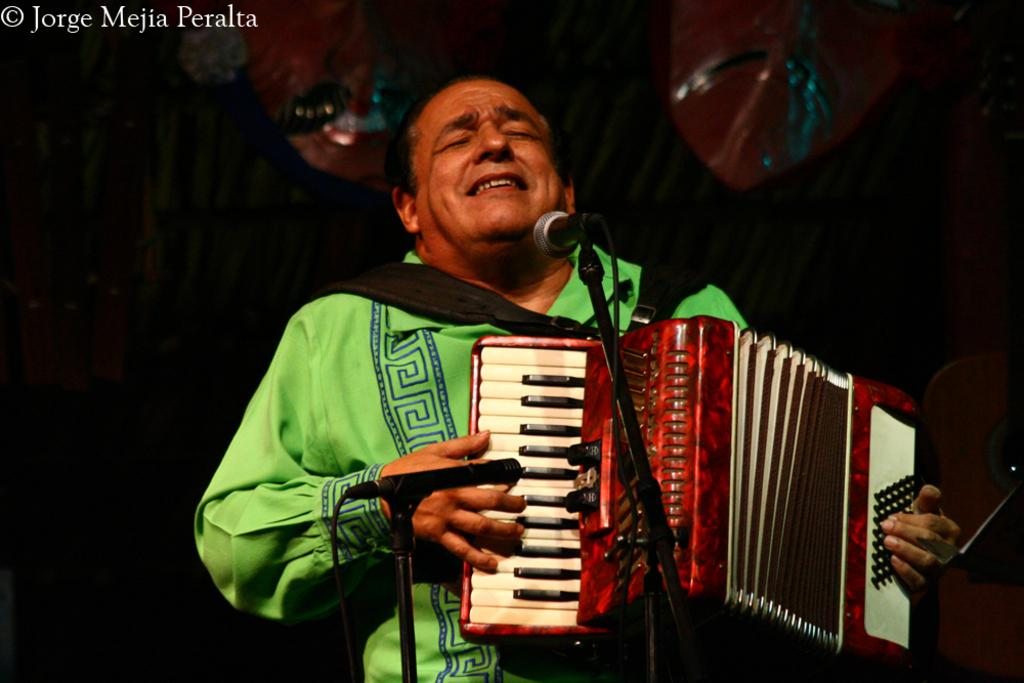What is the man in the image doing? The man is holding a musical instrument in the image. What might the man be preparing to do with the musical instrument? The man might be preparing to play the musical instrument. What is placed in front of the man? There are microphones placed in front of the man. What can be seen in the background of the image? There is a curtain in the background of the image. What is associated with the curtain in the image? There are decorations associated with the curtain. How many cats are sitting on the umbrella in the image? There are no cats or umbrellas present in the image. 